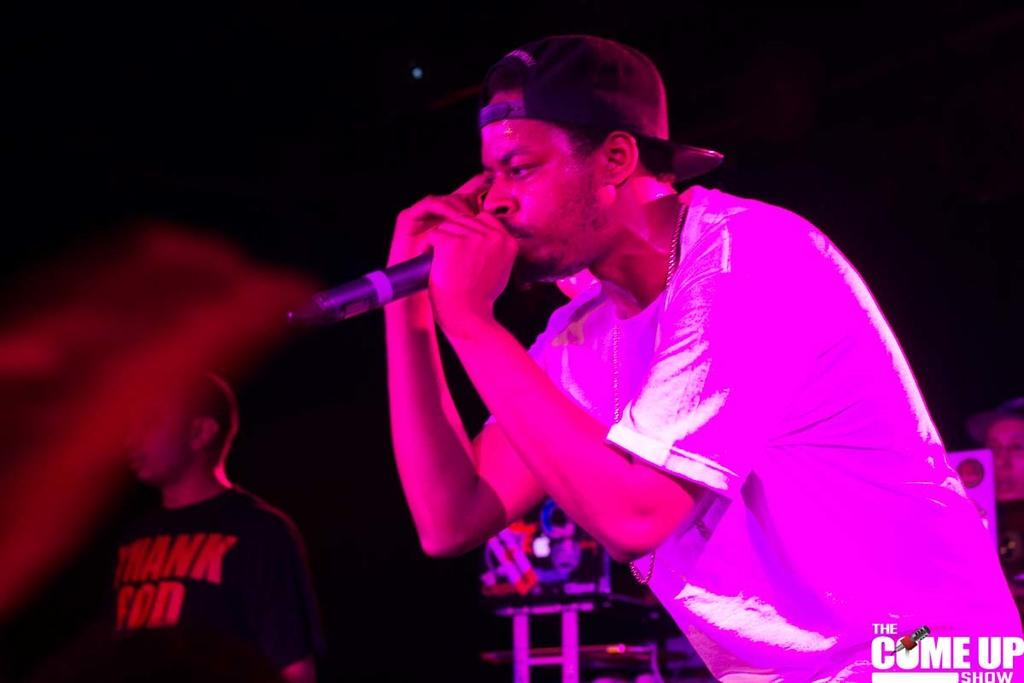What is the person in the image holding? The person is holding a microphone in the image. Can you describe the background of the image? The background of the image is dark. How many other people are visible in the image? There are two other people visible in the image. Where is the person on the right side of the image located? The person on the right side of the image is located to the right of the person holding the microphone. What type of comb is the person using to eat their meal in the image? There is no comb or meal present in the image; the person is holding a microphone. 